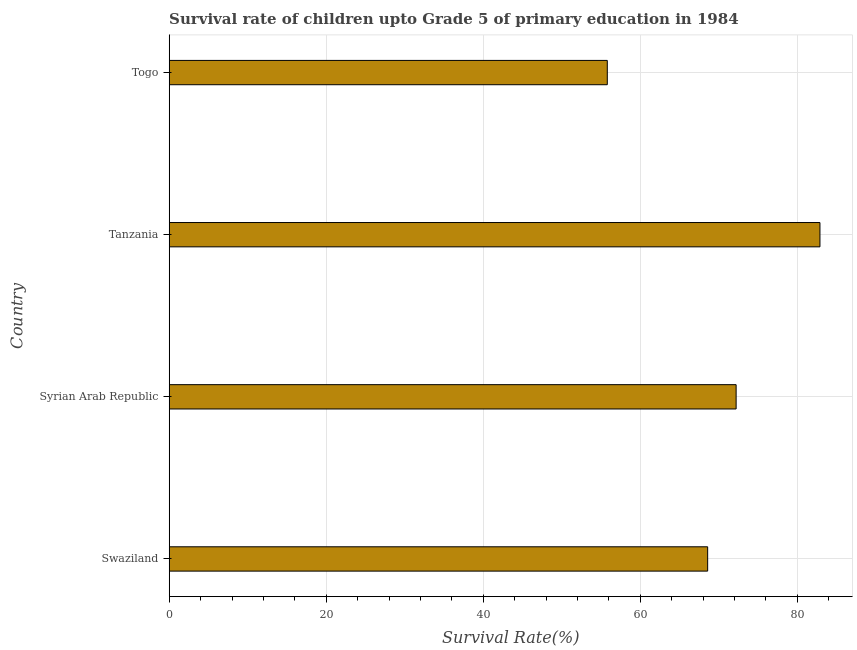What is the title of the graph?
Provide a succinct answer. Survival rate of children upto Grade 5 of primary education in 1984 . What is the label or title of the X-axis?
Your answer should be compact. Survival Rate(%). What is the label or title of the Y-axis?
Give a very brief answer. Country. What is the survival rate in Togo?
Provide a succinct answer. 55.8. Across all countries, what is the maximum survival rate?
Provide a succinct answer. 82.88. Across all countries, what is the minimum survival rate?
Give a very brief answer. 55.8. In which country was the survival rate maximum?
Provide a short and direct response. Tanzania. In which country was the survival rate minimum?
Your answer should be very brief. Togo. What is the sum of the survival rate?
Provide a succinct answer. 279.47. What is the difference between the survival rate in Syrian Arab Republic and Togo?
Your response must be concise. 16.41. What is the average survival rate per country?
Make the answer very short. 69.87. What is the median survival rate?
Provide a short and direct response. 70.39. In how many countries, is the survival rate greater than 76 %?
Offer a very short reply. 1. What is the ratio of the survival rate in Swaziland to that in Tanzania?
Your response must be concise. 0.83. Is the difference between the survival rate in Tanzania and Togo greater than the difference between any two countries?
Make the answer very short. Yes. What is the difference between the highest and the second highest survival rate?
Make the answer very short. 10.68. Is the sum of the survival rate in Swaziland and Tanzania greater than the maximum survival rate across all countries?
Ensure brevity in your answer.  Yes. What is the difference between the highest and the lowest survival rate?
Ensure brevity in your answer.  27.08. In how many countries, is the survival rate greater than the average survival rate taken over all countries?
Provide a short and direct response. 2. How many bars are there?
Provide a short and direct response. 4. How many countries are there in the graph?
Provide a short and direct response. 4. What is the Survival Rate(%) of Swaziland?
Offer a very short reply. 68.58. What is the Survival Rate(%) of Syrian Arab Republic?
Offer a very short reply. 72.21. What is the Survival Rate(%) of Tanzania?
Offer a terse response. 82.88. What is the Survival Rate(%) of Togo?
Ensure brevity in your answer.  55.8. What is the difference between the Survival Rate(%) in Swaziland and Syrian Arab Republic?
Make the answer very short. -3.63. What is the difference between the Survival Rate(%) in Swaziland and Tanzania?
Provide a succinct answer. -14.3. What is the difference between the Survival Rate(%) in Swaziland and Togo?
Ensure brevity in your answer.  12.78. What is the difference between the Survival Rate(%) in Syrian Arab Republic and Tanzania?
Your answer should be compact. -10.68. What is the difference between the Survival Rate(%) in Syrian Arab Republic and Togo?
Provide a short and direct response. 16.41. What is the difference between the Survival Rate(%) in Tanzania and Togo?
Provide a short and direct response. 27.08. What is the ratio of the Survival Rate(%) in Swaziland to that in Tanzania?
Provide a succinct answer. 0.83. What is the ratio of the Survival Rate(%) in Swaziland to that in Togo?
Your response must be concise. 1.23. What is the ratio of the Survival Rate(%) in Syrian Arab Republic to that in Tanzania?
Your answer should be very brief. 0.87. What is the ratio of the Survival Rate(%) in Syrian Arab Republic to that in Togo?
Provide a succinct answer. 1.29. What is the ratio of the Survival Rate(%) in Tanzania to that in Togo?
Provide a succinct answer. 1.49. 